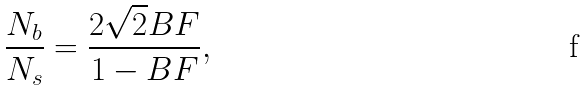<formula> <loc_0><loc_0><loc_500><loc_500>\frac { N _ { b } } { N _ { s } } = \frac { 2 \sqrt { 2 } B F } { 1 - B F } ,</formula> 